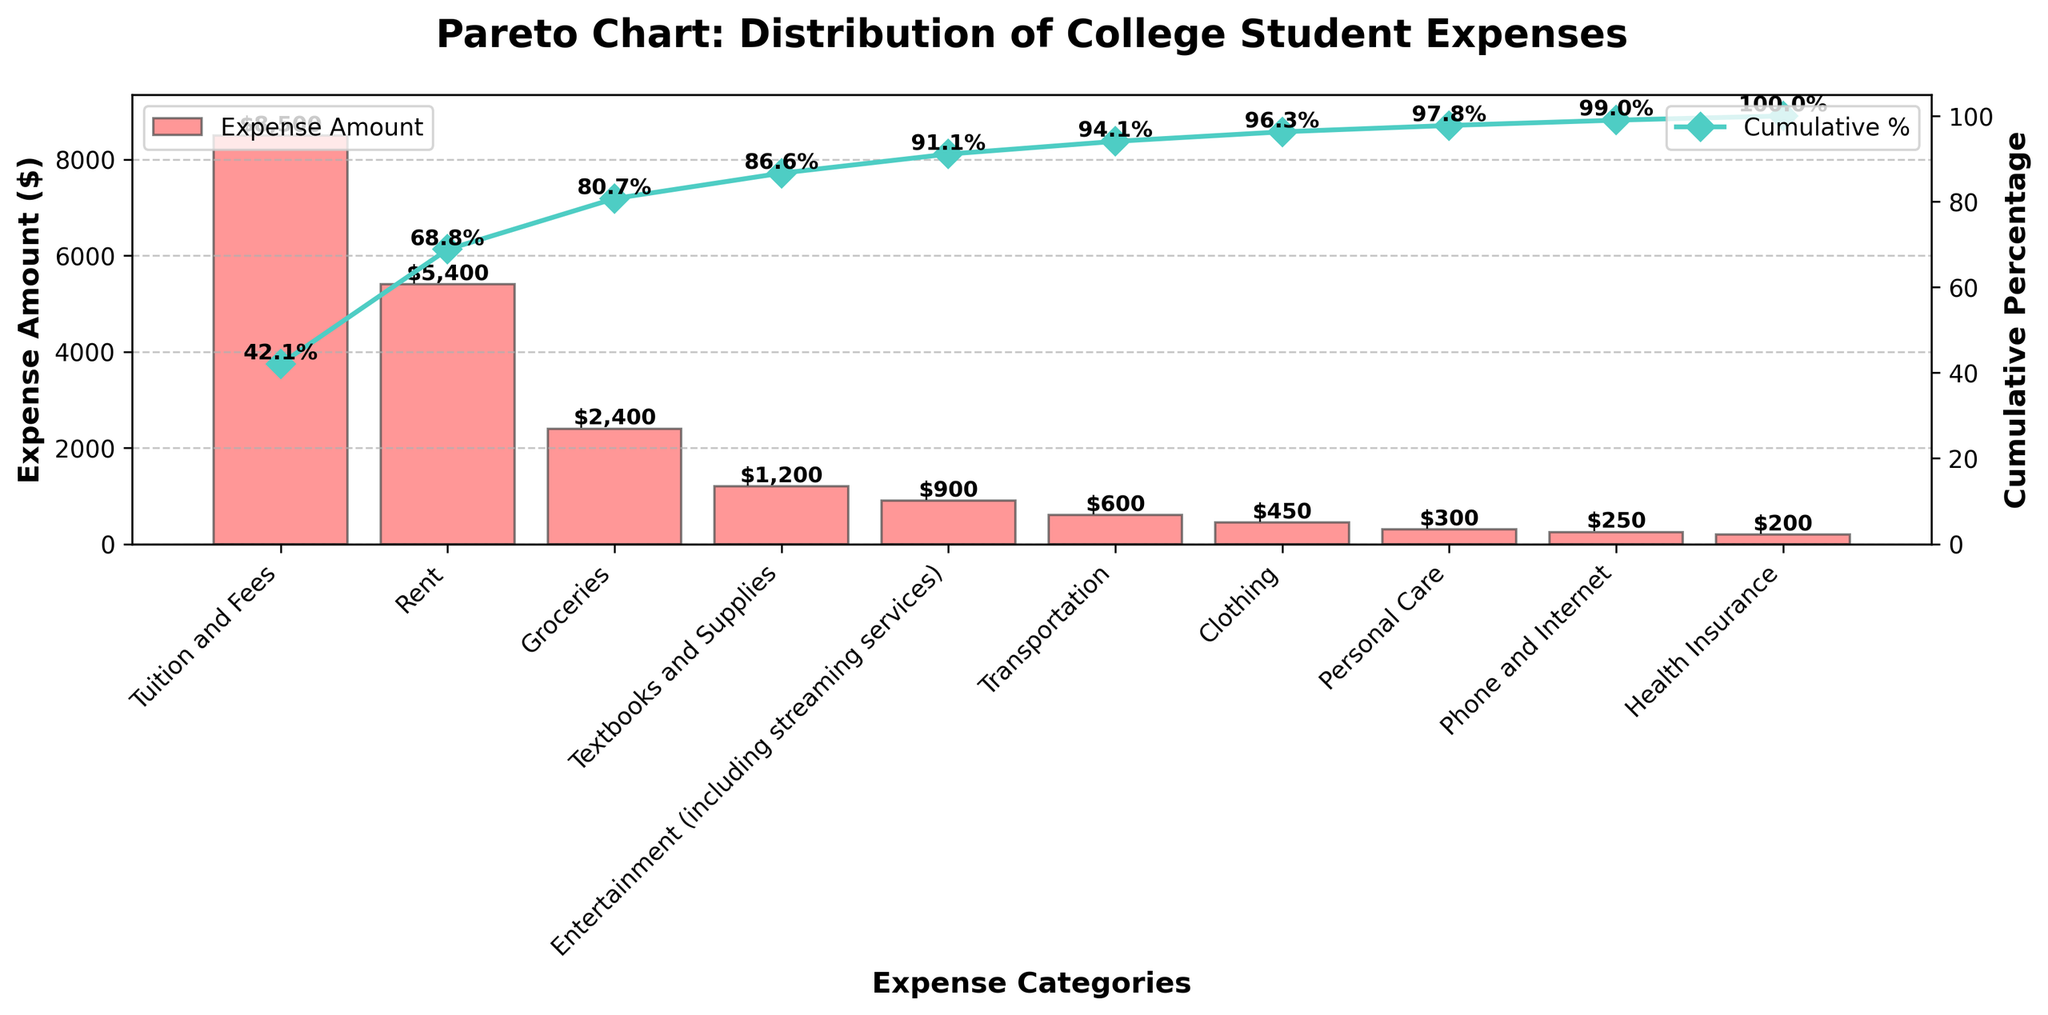What is the title of the chart? The title is typically located at the top of the chart and is displayed in a large, bold font.
Answer: Pareto Chart: Distribution of College Student Expenses What is the highest spending category? The highest spending category is represented by the tallest bar in the chart, which is also likely to be placed at the first position in the x-axis due to the descending order.
Answer: Tuition and Fees How much do college students spend on Rent? The expense amount for Rent can be identified by looking at the height of the corresponding bar and the labeled value above it.
Answer: $5,400 What is the total combined expense for Groceries and Textbooks and Supplies? Sum the expenses for Groceries ($2,400) and Textbooks and Supplies ($1,200).
Answer: $3,600 Which spending category has the lowest expense? The lowest spending category is represented by the shortest bar in the chart, which is also likely to be placed at the last position in the x-axis due to the descending order.
Answer: Health Insurance What cumulative percentage does Rent contribute to? Identify the cumulative percentage value labeled on the chart at the point corresponding to the Rent category on the x-axis.
Answer: (Varies by chart; equivalent to its marked percentage) Approximately, what percentage of the total expenses is contributed by Tuition and Fees and Rent combined? Add the expenses for Tuition and Fees ($8,500) and Rent ($5,400), then divide by the total expenses, multiplying by 100 to get the percentage.
Answer: 67.3% How does the expense for Entertainment compare to the expense for Groceries? Compare the heights of the bars or the labeled values above them, indicating that Entertainment expenses are lower than Groceries.
Answer: Entertainment is lower than Groceries At what category does the cumulative percentage first exceed 50%? Identify the point at which the cumulative percentage line crosses the 50% mark, and note the category at the corresponding position on the x-axis.
Answer: Rent What are the colors used to represent the bars and the cumulative line in the chart? Observe the colors of the bars and the line in the chart. Typically, the bars are in one color and the line in another distinctive but complementary color.
Answer: Bars: red; Line: teal 